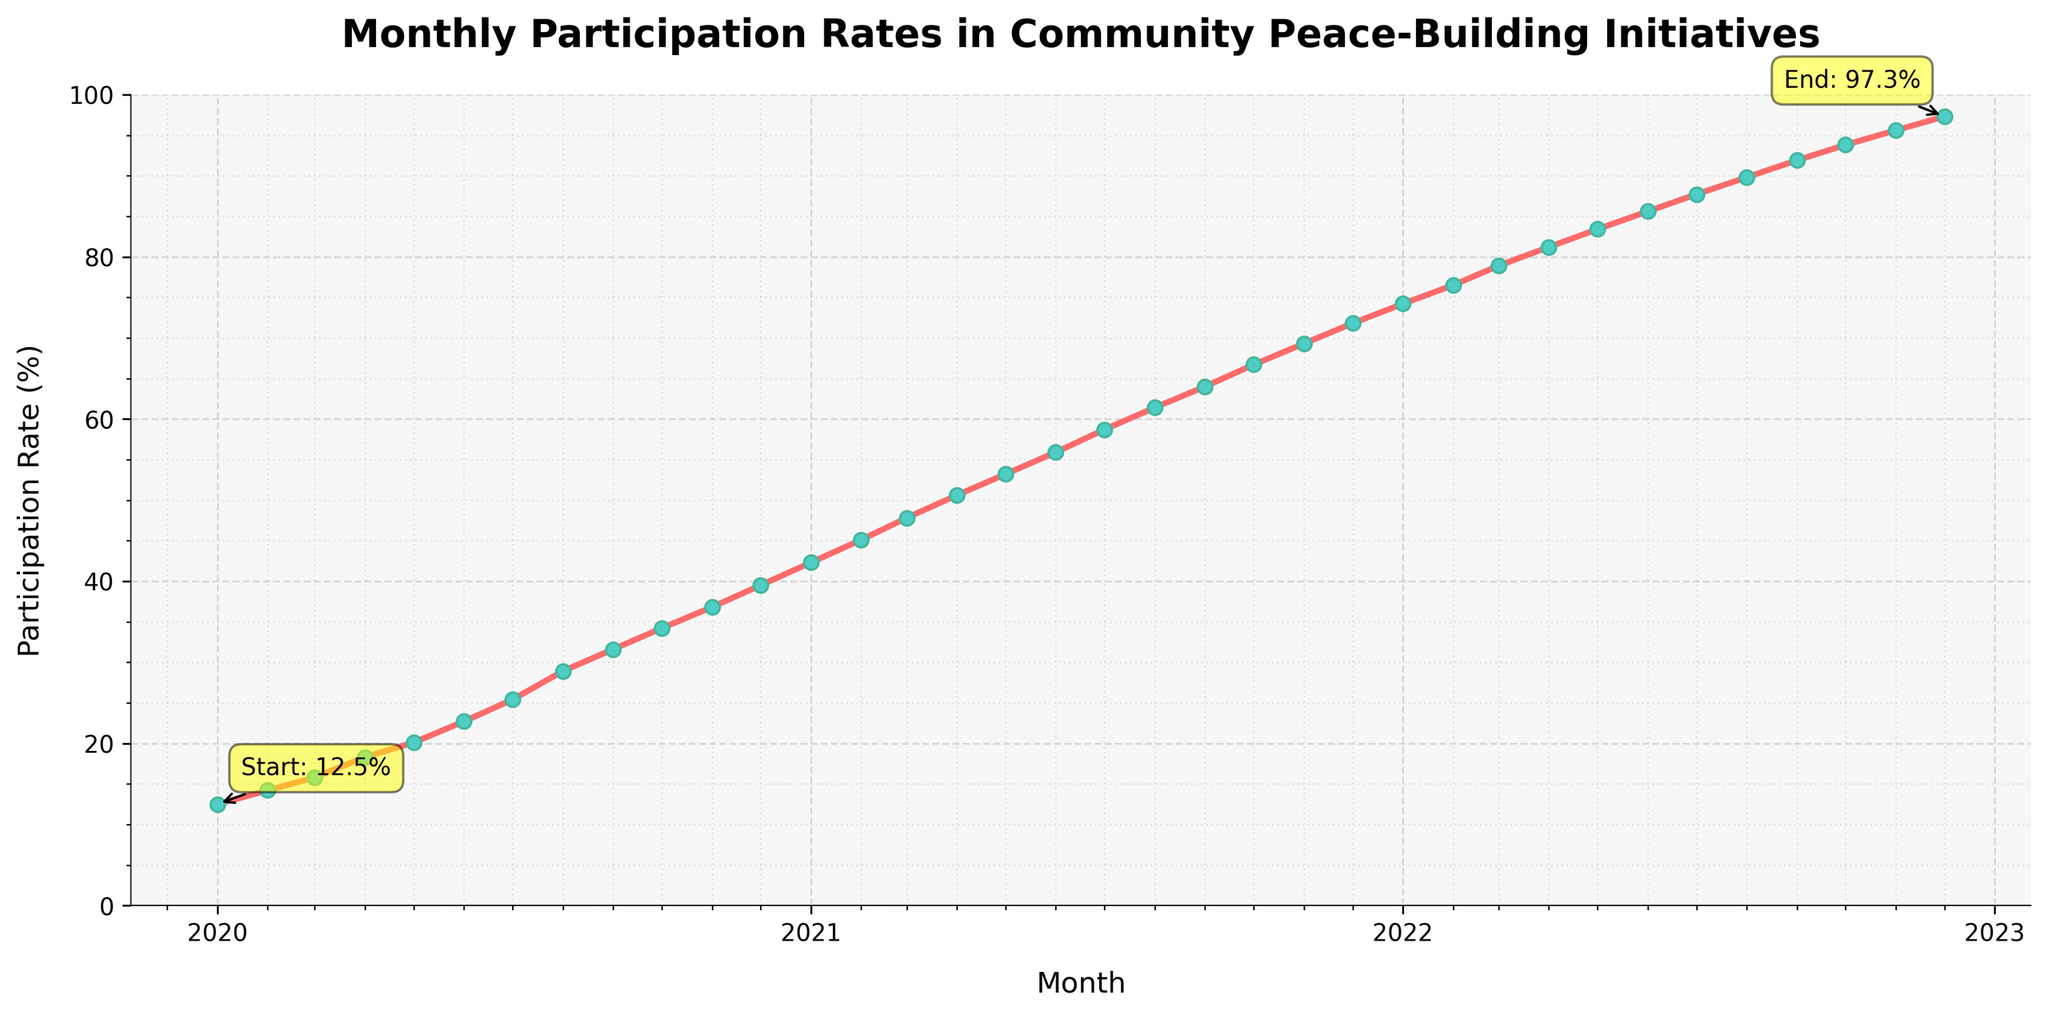What is the participation rate in January 2020? The participation rate in January 2020 is the first data point on the chart.
Answer: 12.5% What's the average participation rate over the entire period? Sum all the monthly participation rates from January 2020 to December 2022 and divide by the number of months (36 months). \( (12.5 + 14.2 + 15.8 + \ldots + 97.3) / 36 = 54.7 \)
Answer: 54.7% How much did the participation rate increase from January 2020 to December 2022? Subtract the participation rate in January 2020 from the participation rate in December 2022. \(97.3 - 12.5 = 84.8\)
Answer: 84.8% In which month did the participation rate first exceed 50%? Locate the point where the participation rate crosses the 50% mark and note the corresponding month.
Answer: April 2021 Compare the participation rate between January 2021 and January 2022. Which is higher? Check the participation rates for January 2021 and January 2022 and compare them. January 2021 has a rate of 42.3%, and January 2022 has a rate of 74.2%.
Answer: January 2022 Which time period shows the fastest increase in participation rates? Identify the period where the gap between consecutive months is the largest by visually assessing the steepness of the curve. The increase appears to be steady, without a dramatically steeper section.
Answer: Steady increase Is there any month where the participation rate decreased? Scan the line chart for any downward trend between consecutive months. There are no visible decreases; the trend is consistently upward.
Answer: No What's the median participation rate from January 2020 to December 2022? List all 36 monthly participation rates in ascending order and find the middle value (18th and 19th values). These are May 2021 (53.2%) and June 2021 (55.9%). The median is the average of these two values. \( (53.2 + 55.9) / 2 = 54.55 \)
Answer: 54.55% When did the participation rate reach approximately 75%? Locate the point where the participation rate is around 75% and identify the corresponding month.
Answer: January 2022 